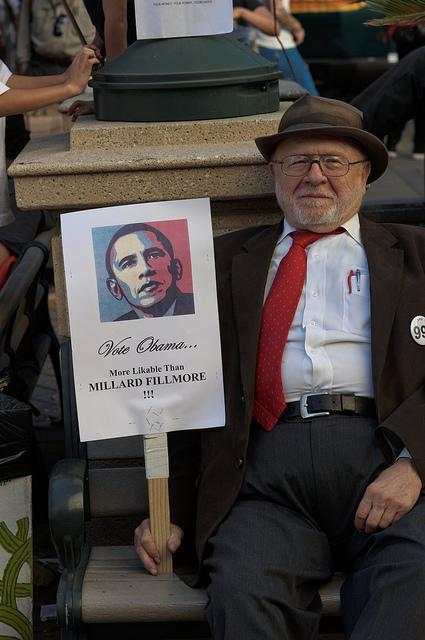Under what circumstance might children wear the red item the man is wearing?
Select the correct answer and articulate reasoning with the following format: 'Answer: answer
Rationale: rationale.'
Options: Swimming, school, military, recreation. Answer: school.
Rationale: It is a necktie and sometimes ties are used as a part of a uniform. 